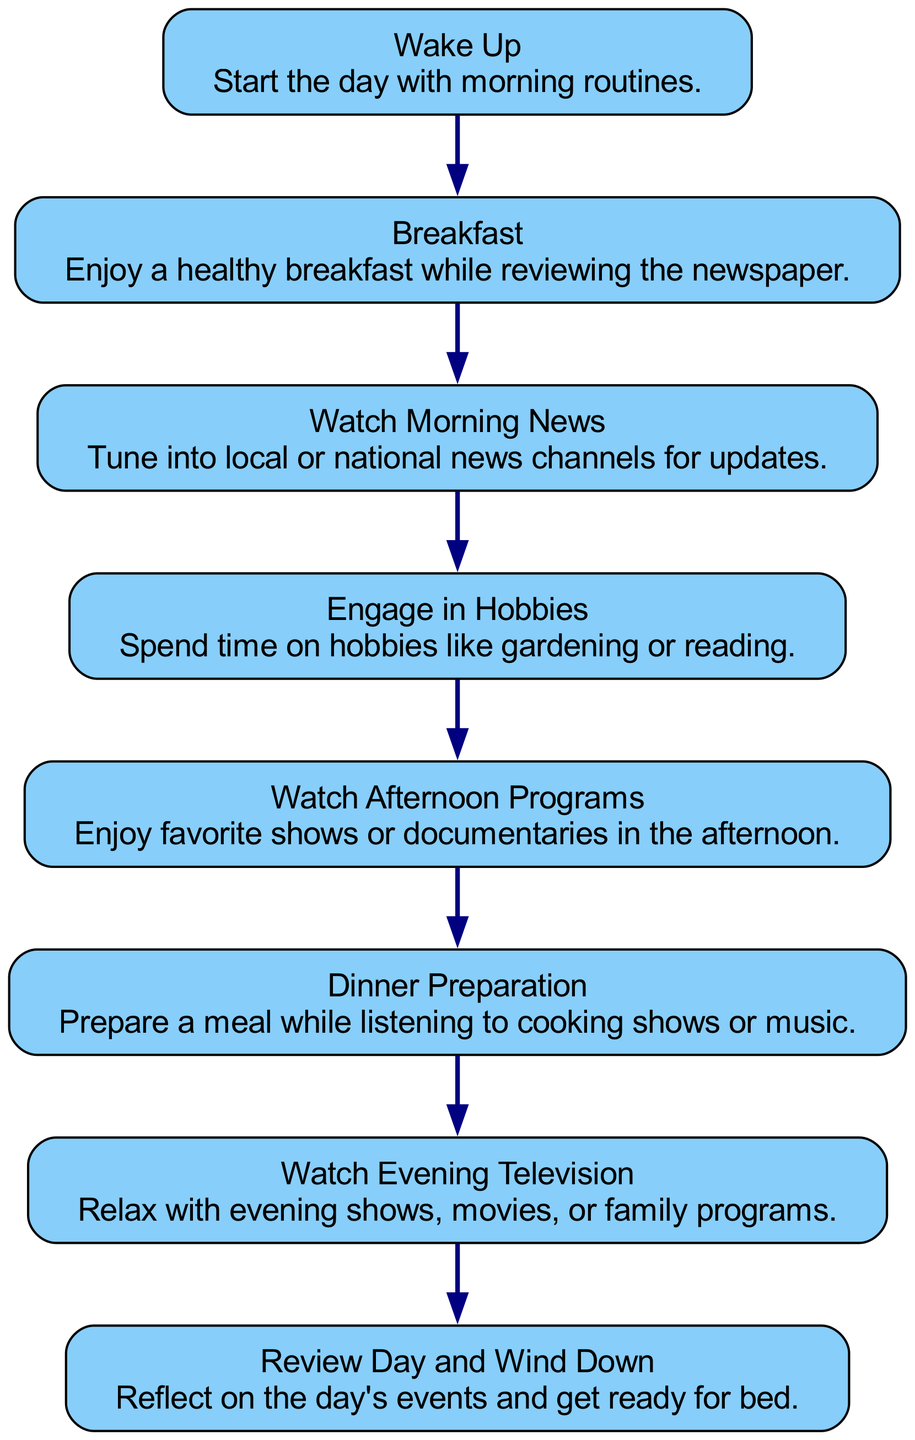What is the first activity in the flow chart? The first node in the flow chart is "Wake Up," which indicates the initial activity of the day.
Answer: Wake Up How many activities are shown in the diagram? There are 8 nodes in the flow chart, each representing a distinct activity in the senior citizen's day.
Answer: 8 What is the last activity before winding down? The last activity before "Review Day and Wind Down" is "Watch Evening Television," which signifies the final viewing before preparing for bed.
Answer: Watch Evening Television What activity is associated with having a meal? The activities "Breakfast" and "Dinner Preparation" are both associated with having meals throughout the day.
Answer: Breakfast, Dinner Preparation What activity follows watching morning news? "Engage in Hobbies" comes directly after "Watch Morning News," suggesting a transition from news consumption to hobby engagement.
Answer: Engage in Hobbies Which hobbies might be engaged in during the day? While "Engage in Hobbies" is the specific node mentioned, it includes activities like gardening or reading, indicating leisure time spent on personal interests.
Answer: Gardening, Reading What activity is connected to listening to cooking shows? "Dinner Preparation" involves preparing a meal while also listening to either cooking shows or music, indicating multitasking during meal prep.
Answer: Dinner Preparation Which node directly leads to watching afternoon programs? "Engage in Hobbies" leads to "Watch Afternoon Programs," showing a progression from personal activities to television viewing later in the day.
Answer: Engage in Hobbies 